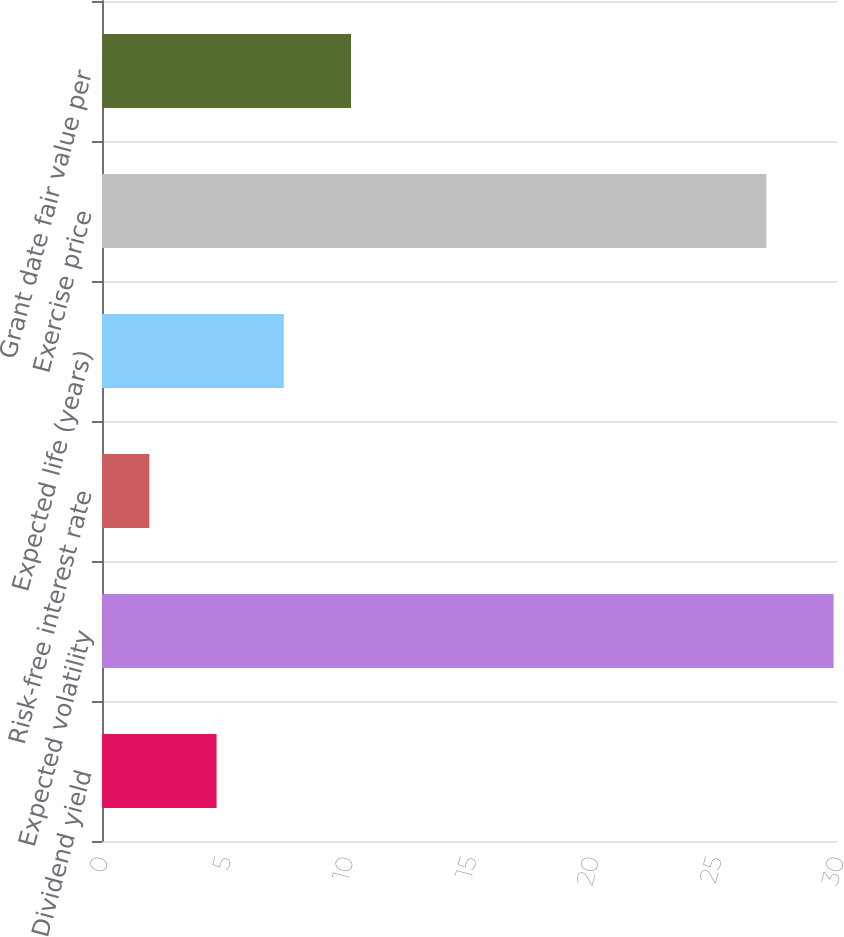Convert chart to OTSL. <chart><loc_0><loc_0><loc_500><loc_500><bar_chart><fcel>Dividend yield<fcel>Expected volatility<fcel>Risk-free interest rate<fcel>Expected life (years)<fcel>Exercise price<fcel>Grant date fair value per<nl><fcel>4.67<fcel>29.82<fcel>1.93<fcel>7.41<fcel>27.08<fcel>10.15<nl></chart> 